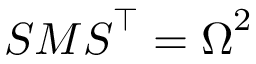<formula> <loc_0><loc_0><loc_500><loc_500>S M S ^ { \intercal } = \Omega ^ { 2 }</formula> 